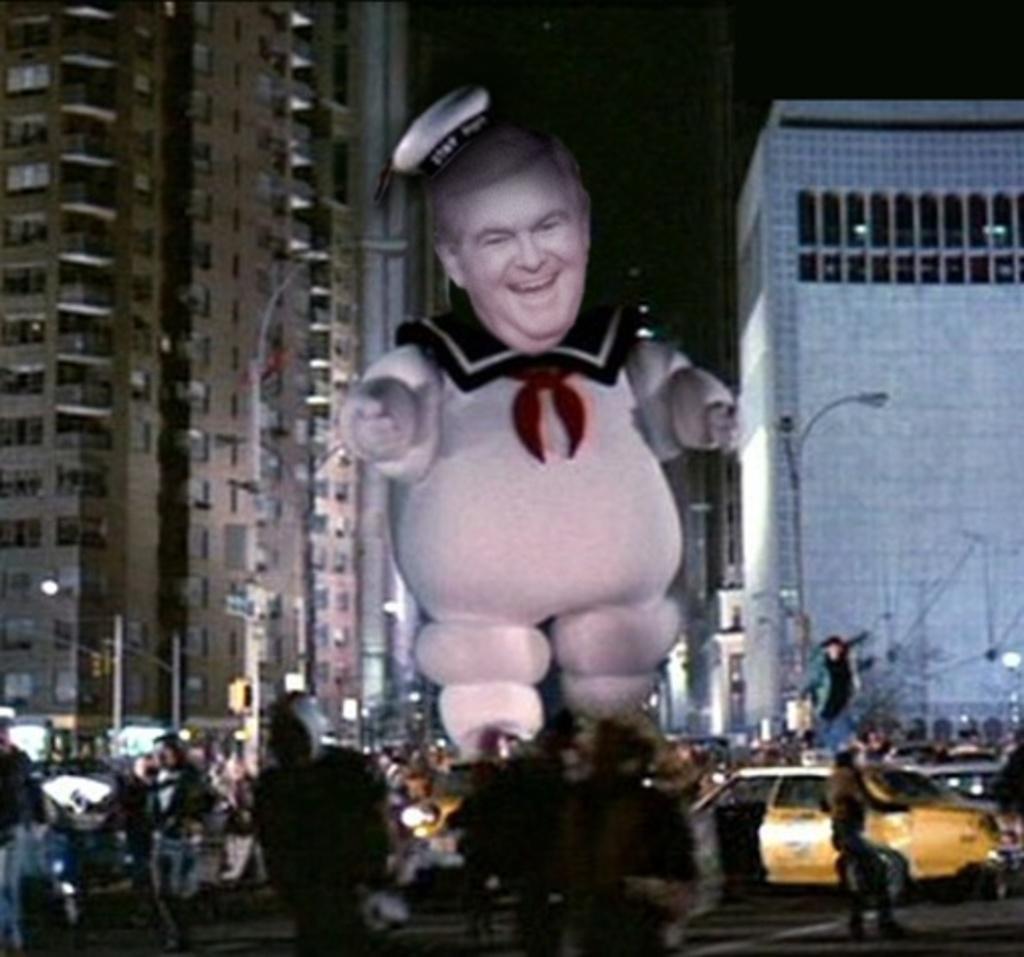Could you give a brief overview of what you see in this image? In this image we can see a statue. At the bottom of the image we can see people and cars on the road. Background of the image, buildings and poles are there. 